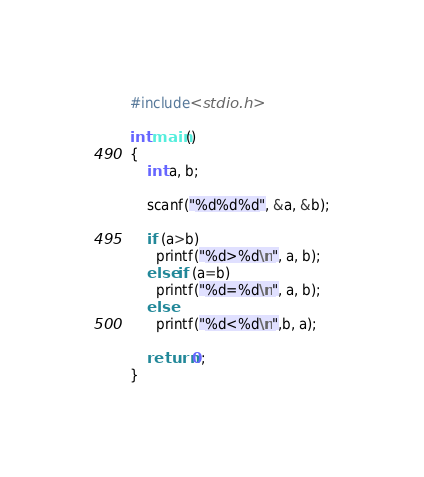Convert code to text. <code><loc_0><loc_0><loc_500><loc_500><_C_>#include<stdio.h>

int main()
{
    int a, b;

    scanf("%d%d%d", &a, &b);

    if (a>b)
      printf("%d>%d\n", a, b);
    else if (a=b)
      printf("%d=%d\n", a, b);
    else 
      printf("%d<%d\n",b, a);
 
    return 0;
}     </code> 